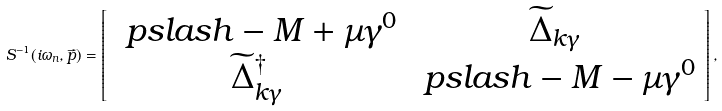<formula> <loc_0><loc_0><loc_500><loc_500>S ^ { - 1 } ( i \omega _ { n } , \vec { p } ) = \left [ \begin{array} { c c } \ p s l a s h - M + \mu \gamma ^ { 0 } & \widetilde { \Delta } _ { k \gamma } \\ \widetilde { \Delta } _ { k \gamma } ^ { \dagger } & \ p s l a s h - M - \mu \gamma ^ { 0 } \end{array} \right ] ,</formula> 